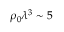Convert formula to latex. <formula><loc_0><loc_0><loc_500><loc_500>\rho _ { 0 } \lambda ^ { 3 } \sim 5</formula> 